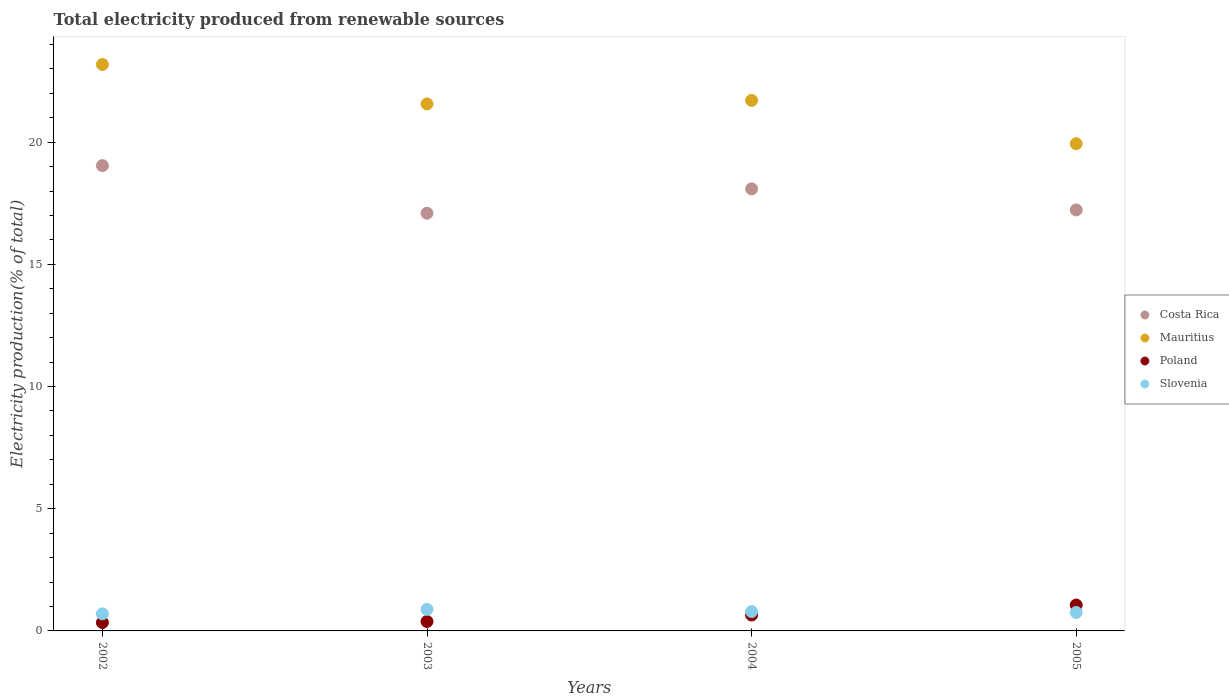How many different coloured dotlines are there?
Your answer should be compact. 4. What is the total electricity produced in Slovenia in 2003?
Your response must be concise. 0.88. Across all years, what is the maximum total electricity produced in Poland?
Offer a terse response. 1.06. Across all years, what is the minimum total electricity produced in Costa Rica?
Provide a succinct answer. 17.09. In which year was the total electricity produced in Poland minimum?
Make the answer very short. 2002. What is the total total electricity produced in Poland in the graph?
Provide a short and direct response. 2.44. What is the difference between the total electricity produced in Slovenia in 2004 and that in 2005?
Your response must be concise. 0.04. What is the difference between the total electricity produced in Costa Rica in 2004 and the total electricity produced in Mauritius in 2002?
Provide a short and direct response. -5.09. What is the average total electricity produced in Mauritius per year?
Keep it short and to the point. 21.6. In the year 2004, what is the difference between the total electricity produced in Slovenia and total electricity produced in Costa Rica?
Provide a short and direct response. -17.3. What is the ratio of the total electricity produced in Poland in 2002 to that in 2004?
Your answer should be compact. 0.53. Is the total electricity produced in Slovenia in 2002 less than that in 2003?
Your answer should be very brief. Yes. What is the difference between the highest and the second highest total electricity produced in Poland?
Ensure brevity in your answer.  0.41. What is the difference between the highest and the lowest total electricity produced in Poland?
Give a very brief answer. 0.72. In how many years, is the total electricity produced in Mauritius greater than the average total electricity produced in Mauritius taken over all years?
Provide a short and direct response. 2. Is the sum of the total electricity produced in Poland in 2002 and 2003 greater than the maximum total electricity produced in Mauritius across all years?
Make the answer very short. No. Is it the case that in every year, the sum of the total electricity produced in Slovenia and total electricity produced in Mauritius  is greater than the sum of total electricity produced in Poland and total electricity produced in Costa Rica?
Keep it short and to the point. No. Is it the case that in every year, the sum of the total electricity produced in Costa Rica and total electricity produced in Slovenia  is greater than the total electricity produced in Mauritius?
Keep it short and to the point. No. Is the total electricity produced in Costa Rica strictly greater than the total electricity produced in Poland over the years?
Your response must be concise. Yes. How many dotlines are there?
Offer a terse response. 4. How many years are there in the graph?
Provide a succinct answer. 4. Are the values on the major ticks of Y-axis written in scientific E-notation?
Keep it short and to the point. No. Does the graph contain any zero values?
Ensure brevity in your answer.  No. Does the graph contain grids?
Your answer should be very brief. No. Where does the legend appear in the graph?
Ensure brevity in your answer.  Center right. How many legend labels are there?
Ensure brevity in your answer.  4. What is the title of the graph?
Ensure brevity in your answer.  Total electricity produced from renewable sources. What is the label or title of the X-axis?
Offer a terse response. Years. What is the Electricity production(% of total) of Costa Rica in 2002?
Provide a short and direct response. 19.04. What is the Electricity production(% of total) in Mauritius in 2002?
Offer a very short reply. 23.18. What is the Electricity production(% of total) of Poland in 2002?
Offer a terse response. 0.34. What is the Electricity production(% of total) of Slovenia in 2002?
Your response must be concise. 0.7. What is the Electricity production(% of total) in Costa Rica in 2003?
Your response must be concise. 17.09. What is the Electricity production(% of total) in Mauritius in 2003?
Offer a terse response. 21.57. What is the Electricity production(% of total) in Poland in 2003?
Give a very brief answer. 0.39. What is the Electricity production(% of total) in Slovenia in 2003?
Ensure brevity in your answer.  0.88. What is the Electricity production(% of total) in Costa Rica in 2004?
Your response must be concise. 18.09. What is the Electricity production(% of total) in Mauritius in 2004?
Make the answer very short. 21.71. What is the Electricity production(% of total) in Poland in 2004?
Offer a terse response. 0.65. What is the Electricity production(% of total) of Slovenia in 2004?
Keep it short and to the point. 0.79. What is the Electricity production(% of total) of Costa Rica in 2005?
Your answer should be very brief. 17.23. What is the Electricity production(% of total) of Mauritius in 2005?
Your answer should be very brief. 19.94. What is the Electricity production(% of total) of Poland in 2005?
Give a very brief answer. 1.06. What is the Electricity production(% of total) in Slovenia in 2005?
Provide a short and direct response. 0.75. Across all years, what is the maximum Electricity production(% of total) in Costa Rica?
Offer a terse response. 19.04. Across all years, what is the maximum Electricity production(% of total) of Mauritius?
Your answer should be compact. 23.18. Across all years, what is the maximum Electricity production(% of total) in Poland?
Provide a succinct answer. 1.06. Across all years, what is the maximum Electricity production(% of total) in Slovenia?
Your answer should be compact. 0.88. Across all years, what is the minimum Electricity production(% of total) of Costa Rica?
Your answer should be very brief. 17.09. Across all years, what is the minimum Electricity production(% of total) in Mauritius?
Offer a terse response. 19.94. Across all years, what is the minimum Electricity production(% of total) in Poland?
Offer a very short reply. 0.34. Across all years, what is the minimum Electricity production(% of total) of Slovenia?
Ensure brevity in your answer.  0.7. What is the total Electricity production(% of total) in Costa Rica in the graph?
Give a very brief answer. 71.45. What is the total Electricity production(% of total) in Mauritius in the graph?
Give a very brief answer. 86.39. What is the total Electricity production(% of total) in Poland in the graph?
Offer a very short reply. 2.44. What is the total Electricity production(% of total) of Slovenia in the graph?
Your answer should be compact. 3.13. What is the difference between the Electricity production(% of total) in Costa Rica in 2002 and that in 2003?
Keep it short and to the point. 1.95. What is the difference between the Electricity production(% of total) of Mauritius in 2002 and that in 2003?
Offer a terse response. 1.61. What is the difference between the Electricity production(% of total) of Poland in 2002 and that in 2003?
Your answer should be very brief. -0.04. What is the difference between the Electricity production(% of total) in Slovenia in 2002 and that in 2003?
Offer a terse response. -0.18. What is the difference between the Electricity production(% of total) in Costa Rica in 2002 and that in 2004?
Ensure brevity in your answer.  0.95. What is the difference between the Electricity production(% of total) of Mauritius in 2002 and that in 2004?
Keep it short and to the point. 1.47. What is the difference between the Electricity production(% of total) in Poland in 2002 and that in 2004?
Keep it short and to the point. -0.31. What is the difference between the Electricity production(% of total) in Slovenia in 2002 and that in 2004?
Give a very brief answer. -0.09. What is the difference between the Electricity production(% of total) in Costa Rica in 2002 and that in 2005?
Your response must be concise. 1.81. What is the difference between the Electricity production(% of total) of Mauritius in 2002 and that in 2005?
Offer a terse response. 3.24. What is the difference between the Electricity production(% of total) of Poland in 2002 and that in 2005?
Your response must be concise. -0.72. What is the difference between the Electricity production(% of total) of Slovenia in 2002 and that in 2005?
Give a very brief answer. -0.06. What is the difference between the Electricity production(% of total) of Costa Rica in 2003 and that in 2004?
Offer a very short reply. -1. What is the difference between the Electricity production(% of total) of Mauritius in 2003 and that in 2004?
Keep it short and to the point. -0.14. What is the difference between the Electricity production(% of total) in Poland in 2003 and that in 2004?
Ensure brevity in your answer.  -0.27. What is the difference between the Electricity production(% of total) in Slovenia in 2003 and that in 2004?
Offer a terse response. 0.09. What is the difference between the Electricity production(% of total) in Costa Rica in 2003 and that in 2005?
Your answer should be compact. -0.13. What is the difference between the Electricity production(% of total) of Mauritius in 2003 and that in 2005?
Make the answer very short. 1.63. What is the difference between the Electricity production(% of total) of Poland in 2003 and that in 2005?
Offer a terse response. -0.67. What is the difference between the Electricity production(% of total) in Slovenia in 2003 and that in 2005?
Your answer should be compact. 0.13. What is the difference between the Electricity production(% of total) in Costa Rica in 2004 and that in 2005?
Provide a succinct answer. 0.86. What is the difference between the Electricity production(% of total) in Mauritius in 2004 and that in 2005?
Make the answer very short. 1.77. What is the difference between the Electricity production(% of total) of Poland in 2004 and that in 2005?
Keep it short and to the point. -0.41. What is the difference between the Electricity production(% of total) in Slovenia in 2004 and that in 2005?
Offer a very short reply. 0.04. What is the difference between the Electricity production(% of total) in Costa Rica in 2002 and the Electricity production(% of total) in Mauritius in 2003?
Your answer should be very brief. -2.53. What is the difference between the Electricity production(% of total) of Costa Rica in 2002 and the Electricity production(% of total) of Poland in 2003?
Provide a succinct answer. 18.65. What is the difference between the Electricity production(% of total) in Costa Rica in 2002 and the Electricity production(% of total) in Slovenia in 2003?
Provide a succinct answer. 18.16. What is the difference between the Electricity production(% of total) of Mauritius in 2002 and the Electricity production(% of total) of Poland in 2003?
Offer a terse response. 22.79. What is the difference between the Electricity production(% of total) of Mauritius in 2002 and the Electricity production(% of total) of Slovenia in 2003?
Your answer should be compact. 22.3. What is the difference between the Electricity production(% of total) in Poland in 2002 and the Electricity production(% of total) in Slovenia in 2003?
Give a very brief answer. -0.54. What is the difference between the Electricity production(% of total) in Costa Rica in 2002 and the Electricity production(% of total) in Mauritius in 2004?
Your answer should be compact. -2.67. What is the difference between the Electricity production(% of total) of Costa Rica in 2002 and the Electricity production(% of total) of Poland in 2004?
Keep it short and to the point. 18.39. What is the difference between the Electricity production(% of total) of Costa Rica in 2002 and the Electricity production(% of total) of Slovenia in 2004?
Keep it short and to the point. 18.25. What is the difference between the Electricity production(% of total) in Mauritius in 2002 and the Electricity production(% of total) in Poland in 2004?
Make the answer very short. 22.53. What is the difference between the Electricity production(% of total) in Mauritius in 2002 and the Electricity production(% of total) in Slovenia in 2004?
Offer a very short reply. 22.39. What is the difference between the Electricity production(% of total) of Poland in 2002 and the Electricity production(% of total) of Slovenia in 2004?
Keep it short and to the point. -0.45. What is the difference between the Electricity production(% of total) of Costa Rica in 2002 and the Electricity production(% of total) of Mauritius in 2005?
Provide a succinct answer. -0.9. What is the difference between the Electricity production(% of total) in Costa Rica in 2002 and the Electricity production(% of total) in Poland in 2005?
Make the answer very short. 17.98. What is the difference between the Electricity production(% of total) in Costa Rica in 2002 and the Electricity production(% of total) in Slovenia in 2005?
Offer a terse response. 18.29. What is the difference between the Electricity production(% of total) of Mauritius in 2002 and the Electricity production(% of total) of Poland in 2005?
Provide a short and direct response. 22.12. What is the difference between the Electricity production(% of total) in Mauritius in 2002 and the Electricity production(% of total) in Slovenia in 2005?
Offer a terse response. 22.43. What is the difference between the Electricity production(% of total) of Poland in 2002 and the Electricity production(% of total) of Slovenia in 2005?
Ensure brevity in your answer.  -0.41. What is the difference between the Electricity production(% of total) of Costa Rica in 2003 and the Electricity production(% of total) of Mauritius in 2004?
Provide a succinct answer. -4.62. What is the difference between the Electricity production(% of total) of Costa Rica in 2003 and the Electricity production(% of total) of Poland in 2004?
Your response must be concise. 16.44. What is the difference between the Electricity production(% of total) in Costa Rica in 2003 and the Electricity production(% of total) in Slovenia in 2004?
Keep it short and to the point. 16.3. What is the difference between the Electricity production(% of total) of Mauritius in 2003 and the Electricity production(% of total) of Poland in 2004?
Your answer should be very brief. 20.91. What is the difference between the Electricity production(% of total) in Mauritius in 2003 and the Electricity production(% of total) in Slovenia in 2004?
Provide a succinct answer. 20.77. What is the difference between the Electricity production(% of total) of Poland in 2003 and the Electricity production(% of total) of Slovenia in 2004?
Offer a terse response. -0.41. What is the difference between the Electricity production(% of total) in Costa Rica in 2003 and the Electricity production(% of total) in Mauritius in 2005?
Your response must be concise. -2.84. What is the difference between the Electricity production(% of total) in Costa Rica in 2003 and the Electricity production(% of total) in Poland in 2005?
Give a very brief answer. 16.03. What is the difference between the Electricity production(% of total) in Costa Rica in 2003 and the Electricity production(% of total) in Slovenia in 2005?
Keep it short and to the point. 16.34. What is the difference between the Electricity production(% of total) in Mauritius in 2003 and the Electricity production(% of total) in Poland in 2005?
Keep it short and to the point. 20.51. What is the difference between the Electricity production(% of total) in Mauritius in 2003 and the Electricity production(% of total) in Slovenia in 2005?
Make the answer very short. 20.81. What is the difference between the Electricity production(% of total) in Poland in 2003 and the Electricity production(% of total) in Slovenia in 2005?
Offer a terse response. -0.37. What is the difference between the Electricity production(% of total) of Costa Rica in 2004 and the Electricity production(% of total) of Mauritius in 2005?
Give a very brief answer. -1.85. What is the difference between the Electricity production(% of total) of Costa Rica in 2004 and the Electricity production(% of total) of Poland in 2005?
Provide a short and direct response. 17.03. What is the difference between the Electricity production(% of total) of Costa Rica in 2004 and the Electricity production(% of total) of Slovenia in 2005?
Make the answer very short. 17.33. What is the difference between the Electricity production(% of total) of Mauritius in 2004 and the Electricity production(% of total) of Poland in 2005?
Make the answer very short. 20.65. What is the difference between the Electricity production(% of total) of Mauritius in 2004 and the Electricity production(% of total) of Slovenia in 2005?
Provide a short and direct response. 20.95. What is the difference between the Electricity production(% of total) of Poland in 2004 and the Electricity production(% of total) of Slovenia in 2005?
Ensure brevity in your answer.  -0.1. What is the average Electricity production(% of total) of Costa Rica per year?
Make the answer very short. 17.86. What is the average Electricity production(% of total) of Mauritius per year?
Your response must be concise. 21.6. What is the average Electricity production(% of total) in Poland per year?
Make the answer very short. 0.61. What is the average Electricity production(% of total) of Slovenia per year?
Keep it short and to the point. 0.78. In the year 2002, what is the difference between the Electricity production(% of total) of Costa Rica and Electricity production(% of total) of Mauritius?
Offer a terse response. -4.14. In the year 2002, what is the difference between the Electricity production(% of total) in Costa Rica and Electricity production(% of total) in Poland?
Your response must be concise. 18.7. In the year 2002, what is the difference between the Electricity production(% of total) of Costa Rica and Electricity production(% of total) of Slovenia?
Offer a very short reply. 18.34. In the year 2002, what is the difference between the Electricity production(% of total) in Mauritius and Electricity production(% of total) in Poland?
Offer a terse response. 22.84. In the year 2002, what is the difference between the Electricity production(% of total) of Mauritius and Electricity production(% of total) of Slovenia?
Offer a terse response. 22.48. In the year 2002, what is the difference between the Electricity production(% of total) in Poland and Electricity production(% of total) in Slovenia?
Offer a terse response. -0.36. In the year 2003, what is the difference between the Electricity production(% of total) of Costa Rica and Electricity production(% of total) of Mauritius?
Give a very brief answer. -4.47. In the year 2003, what is the difference between the Electricity production(% of total) of Costa Rica and Electricity production(% of total) of Poland?
Your response must be concise. 16.71. In the year 2003, what is the difference between the Electricity production(% of total) in Costa Rica and Electricity production(% of total) in Slovenia?
Your response must be concise. 16.21. In the year 2003, what is the difference between the Electricity production(% of total) in Mauritius and Electricity production(% of total) in Poland?
Provide a short and direct response. 21.18. In the year 2003, what is the difference between the Electricity production(% of total) in Mauritius and Electricity production(% of total) in Slovenia?
Your answer should be very brief. 20.68. In the year 2003, what is the difference between the Electricity production(% of total) of Poland and Electricity production(% of total) of Slovenia?
Your answer should be very brief. -0.5. In the year 2004, what is the difference between the Electricity production(% of total) in Costa Rica and Electricity production(% of total) in Mauritius?
Provide a short and direct response. -3.62. In the year 2004, what is the difference between the Electricity production(% of total) of Costa Rica and Electricity production(% of total) of Poland?
Ensure brevity in your answer.  17.44. In the year 2004, what is the difference between the Electricity production(% of total) in Costa Rica and Electricity production(% of total) in Slovenia?
Ensure brevity in your answer.  17.3. In the year 2004, what is the difference between the Electricity production(% of total) in Mauritius and Electricity production(% of total) in Poland?
Offer a very short reply. 21.06. In the year 2004, what is the difference between the Electricity production(% of total) in Mauritius and Electricity production(% of total) in Slovenia?
Offer a terse response. 20.92. In the year 2004, what is the difference between the Electricity production(% of total) of Poland and Electricity production(% of total) of Slovenia?
Make the answer very short. -0.14. In the year 2005, what is the difference between the Electricity production(% of total) in Costa Rica and Electricity production(% of total) in Mauritius?
Offer a terse response. -2.71. In the year 2005, what is the difference between the Electricity production(% of total) of Costa Rica and Electricity production(% of total) of Poland?
Offer a terse response. 16.17. In the year 2005, what is the difference between the Electricity production(% of total) of Costa Rica and Electricity production(% of total) of Slovenia?
Provide a succinct answer. 16.47. In the year 2005, what is the difference between the Electricity production(% of total) in Mauritius and Electricity production(% of total) in Poland?
Your answer should be very brief. 18.88. In the year 2005, what is the difference between the Electricity production(% of total) of Mauritius and Electricity production(% of total) of Slovenia?
Make the answer very short. 19.18. In the year 2005, what is the difference between the Electricity production(% of total) in Poland and Electricity production(% of total) in Slovenia?
Offer a terse response. 0.31. What is the ratio of the Electricity production(% of total) in Costa Rica in 2002 to that in 2003?
Your response must be concise. 1.11. What is the ratio of the Electricity production(% of total) of Mauritius in 2002 to that in 2003?
Ensure brevity in your answer.  1.07. What is the ratio of the Electricity production(% of total) in Poland in 2002 to that in 2003?
Your answer should be compact. 0.89. What is the ratio of the Electricity production(% of total) in Slovenia in 2002 to that in 2003?
Your answer should be compact. 0.79. What is the ratio of the Electricity production(% of total) in Costa Rica in 2002 to that in 2004?
Your answer should be very brief. 1.05. What is the ratio of the Electricity production(% of total) of Mauritius in 2002 to that in 2004?
Your answer should be very brief. 1.07. What is the ratio of the Electricity production(% of total) in Poland in 2002 to that in 2004?
Offer a very short reply. 0.53. What is the ratio of the Electricity production(% of total) of Slovenia in 2002 to that in 2004?
Your answer should be compact. 0.88. What is the ratio of the Electricity production(% of total) of Costa Rica in 2002 to that in 2005?
Your answer should be very brief. 1.11. What is the ratio of the Electricity production(% of total) of Mauritius in 2002 to that in 2005?
Your answer should be compact. 1.16. What is the ratio of the Electricity production(% of total) of Poland in 2002 to that in 2005?
Your answer should be compact. 0.32. What is the ratio of the Electricity production(% of total) of Slovenia in 2002 to that in 2005?
Provide a short and direct response. 0.93. What is the ratio of the Electricity production(% of total) of Costa Rica in 2003 to that in 2004?
Keep it short and to the point. 0.94. What is the ratio of the Electricity production(% of total) of Mauritius in 2003 to that in 2004?
Offer a terse response. 0.99. What is the ratio of the Electricity production(% of total) in Poland in 2003 to that in 2004?
Offer a very short reply. 0.59. What is the ratio of the Electricity production(% of total) in Slovenia in 2003 to that in 2004?
Offer a very short reply. 1.11. What is the ratio of the Electricity production(% of total) in Costa Rica in 2003 to that in 2005?
Your answer should be compact. 0.99. What is the ratio of the Electricity production(% of total) of Mauritius in 2003 to that in 2005?
Make the answer very short. 1.08. What is the ratio of the Electricity production(% of total) in Poland in 2003 to that in 2005?
Provide a short and direct response. 0.36. What is the ratio of the Electricity production(% of total) of Slovenia in 2003 to that in 2005?
Your answer should be compact. 1.17. What is the ratio of the Electricity production(% of total) of Mauritius in 2004 to that in 2005?
Offer a terse response. 1.09. What is the ratio of the Electricity production(% of total) of Poland in 2004 to that in 2005?
Make the answer very short. 0.61. What is the ratio of the Electricity production(% of total) in Slovenia in 2004 to that in 2005?
Offer a terse response. 1.05. What is the difference between the highest and the second highest Electricity production(% of total) in Costa Rica?
Keep it short and to the point. 0.95. What is the difference between the highest and the second highest Electricity production(% of total) of Mauritius?
Make the answer very short. 1.47. What is the difference between the highest and the second highest Electricity production(% of total) of Poland?
Provide a short and direct response. 0.41. What is the difference between the highest and the second highest Electricity production(% of total) of Slovenia?
Keep it short and to the point. 0.09. What is the difference between the highest and the lowest Electricity production(% of total) in Costa Rica?
Keep it short and to the point. 1.95. What is the difference between the highest and the lowest Electricity production(% of total) in Mauritius?
Give a very brief answer. 3.24. What is the difference between the highest and the lowest Electricity production(% of total) of Poland?
Give a very brief answer. 0.72. What is the difference between the highest and the lowest Electricity production(% of total) of Slovenia?
Provide a short and direct response. 0.18. 